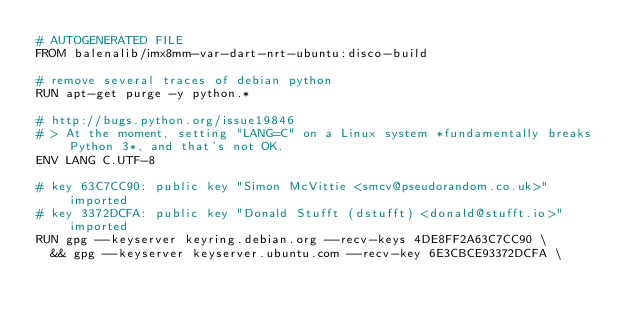Convert code to text. <code><loc_0><loc_0><loc_500><loc_500><_Dockerfile_># AUTOGENERATED FILE
FROM balenalib/imx8mm-var-dart-nrt-ubuntu:disco-build

# remove several traces of debian python
RUN apt-get purge -y python.*

# http://bugs.python.org/issue19846
# > At the moment, setting "LANG=C" on a Linux system *fundamentally breaks Python 3*, and that's not OK.
ENV LANG C.UTF-8

# key 63C7CC90: public key "Simon McVittie <smcv@pseudorandom.co.uk>" imported
# key 3372DCFA: public key "Donald Stufft (dstufft) <donald@stufft.io>" imported
RUN gpg --keyserver keyring.debian.org --recv-keys 4DE8FF2A63C7CC90 \
	&& gpg --keyserver keyserver.ubuntu.com --recv-key 6E3CBCE93372DCFA \</code> 